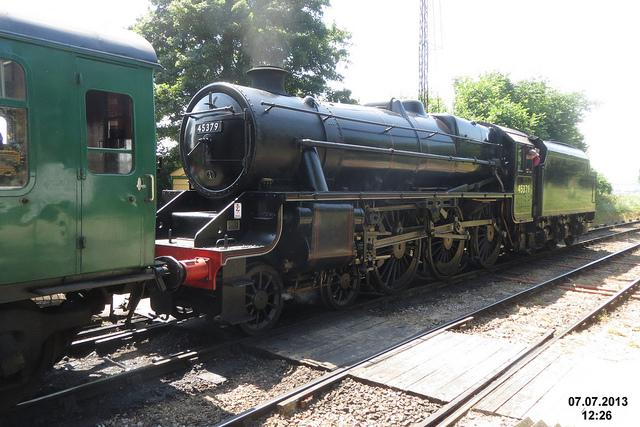Who invented this vehicle? richard trevithick 